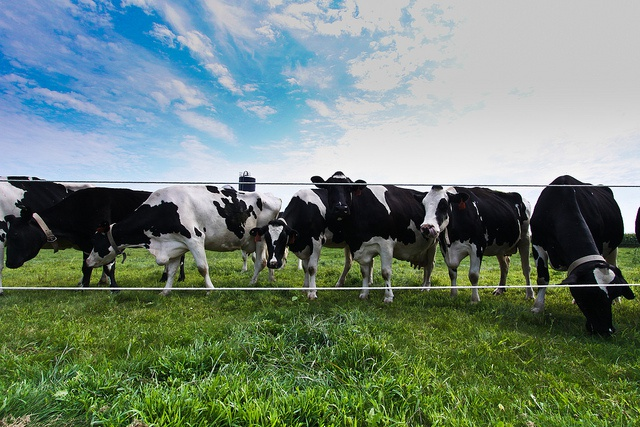Describe the objects in this image and their specific colors. I can see cow in darkgray, black, gray, and lightgray tones, cow in darkgray, black, gray, and white tones, cow in darkgray, black, gray, and lightgray tones, cow in darkgray, black, gray, and lightgray tones, and cow in darkgray, black, white, and gray tones in this image. 